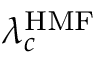Convert formula to latex. <formula><loc_0><loc_0><loc_500><loc_500>\lambda _ { c } ^ { H M F }</formula> 